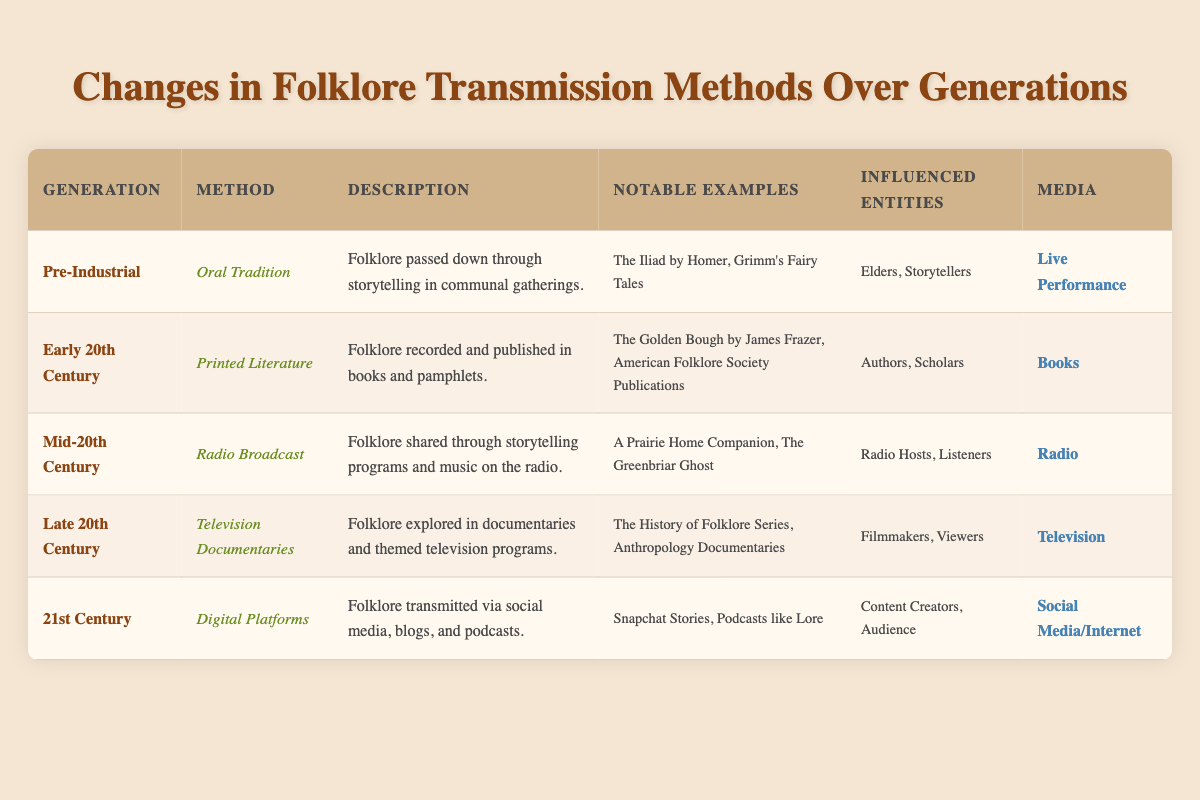What was the folklore transmission method used during the Pre-Industrial generation? According to the table, the folklore transmission method used during the Pre-Industrial generation was "Oral Tradition."
Answer: Oral Tradition Which notable examples are associated with Printed Literature? The table lists two notable examples associated with Printed Literature: "The Golden Bough by James Frazer" and "American Folklore Society Publications."
Answer: The Golden Bough by James Frazer, American Folklore Society Publications True or False: Radio Broadcast was the transmission method in the Late 20th Century. The table specifies that the Late 20th Century used "Television Documentaries" as the transmission method, not Radio Broadcast. Therefore, the statement is false.
Answer: False What media was primarily used for folklore transmission in the 21st Century? The media primarily used for folklore transmission in the 21st Century is "Social Media/Internet," as indicated in the table.
Answer: Social Media/Internet Identify the influenced entities associated with the Oral Tradition method. Referencing the table, the influenced entities associated with the Oral Tradition method are "Elders" and "Storytellers."
Answer: Elders, Storytellers What is the difference in methods between the Early 20th Century and Mid-20th Century? In the Early 20th Century, the method was "Printed Literature," while in the Mid-20th Century, it changed to "Radio Broadcast." Therefore, the difference in methods is from Printed Literature to Radio Broadcast.
Answer: From Printed Literature to Radio Broadcast How many notable examples are mentioned for Digital Platforms? The table lists two notable examples for Digital Platforms: "Snapchat Stories" and "Podcasts like Lore." Therefore, there are two notable examples mentioned.
Answer: 2 Which generation made use of both Television and Radio as media? By examining the table, it is clear that the Late 20th Century utilized "Television" (Television Documentaries) and the Mid-20th Century utilized "Radio" (Radio Broadcast). Therefore, both generations used these media types.
Answer: Late 20th Century and Mid-20th Century What transmission method saw the emergence of digital storytelling techniques? The table indicates that the "Digital Platforms" method in the 21st Century saw the emergence of digital storytelling techniques through social media, blogs, and podcasts.
Answer: Digital Platforms 